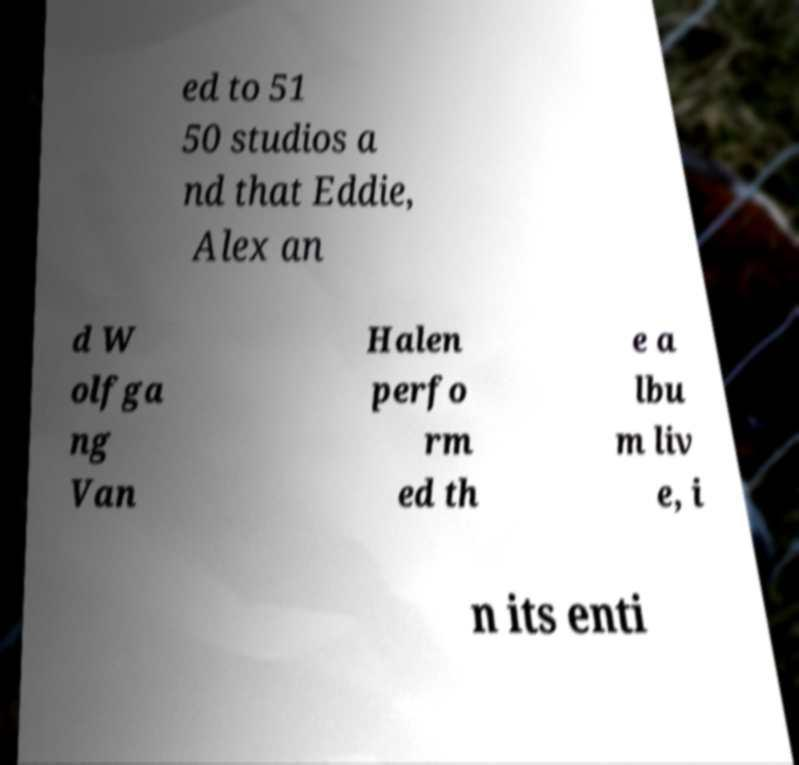Can you accurately transcribe the text from the provided image for me? ed to 51 50 studios a nd that Eddie, Alex an d W olfga ng Van Halen perfo rm ed th e a lbu m liv e, i n its enti 